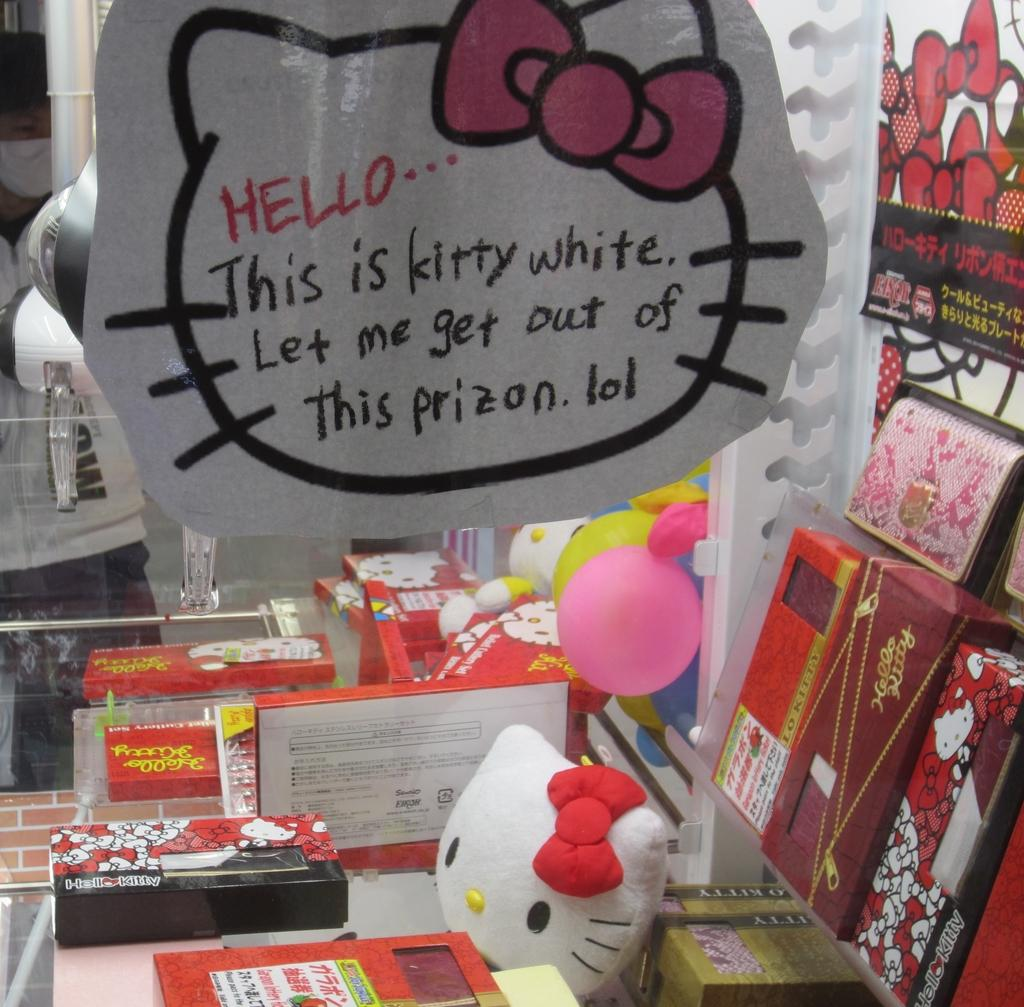<image>
Render a clear and concise summary of the photo. A Hello Kitty display with a sign written by kitty white asking to be let out of their prison. 